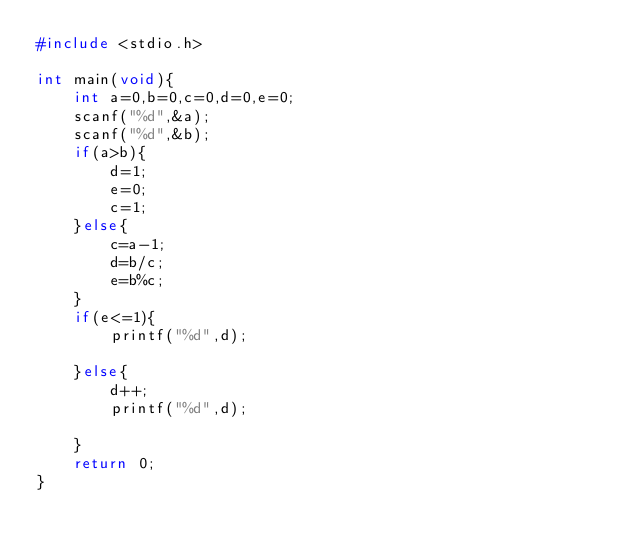Convert code to text. <code><loc_0><loc_0><loc_500><loc_500><_C_>#include <stdio.h>

int main(void){
    int a=0,b=0,c=0,d=0,e=0;
    scanf("%d",&a);
    scanf("%d",&b);
    if(a>b){
        d=1;
        e=0;
        c=1;
    }else{
        c=a-1;
        d=b/c;
        e=b%c;
    }
    if(e<=1){
        printf("%d",d);
        
    }else{
        d++;
        printf("%d",d);
        
    }
    return 0;
}
</code> 